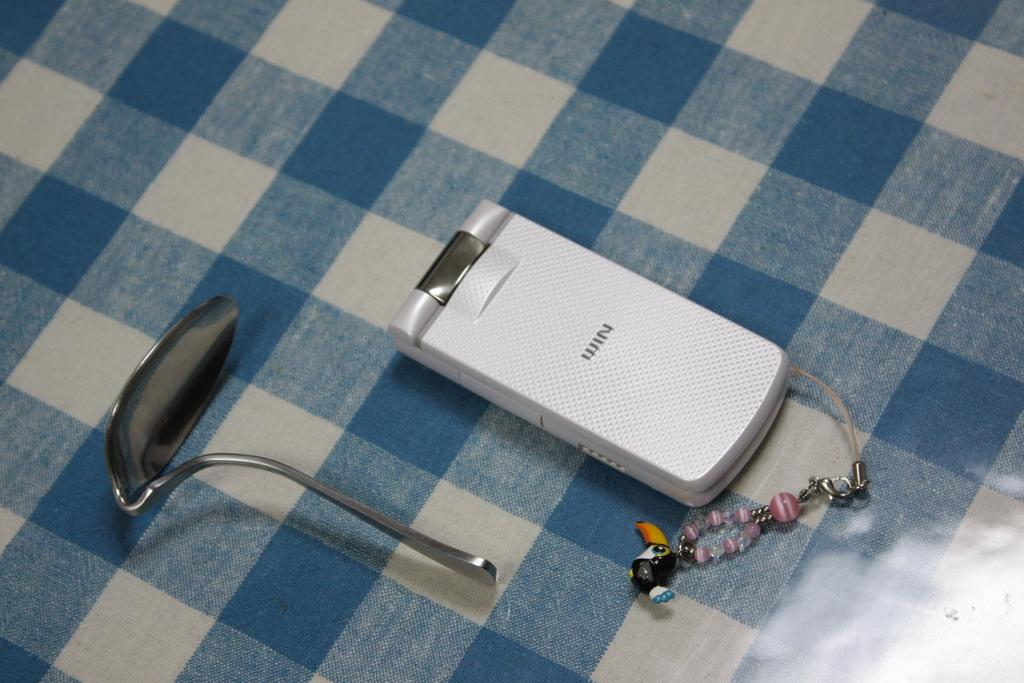<image>
Render a clear and concise summary of the photo. A white cell phone with the word "Win" engraved on it sits next to a bent spoon. 